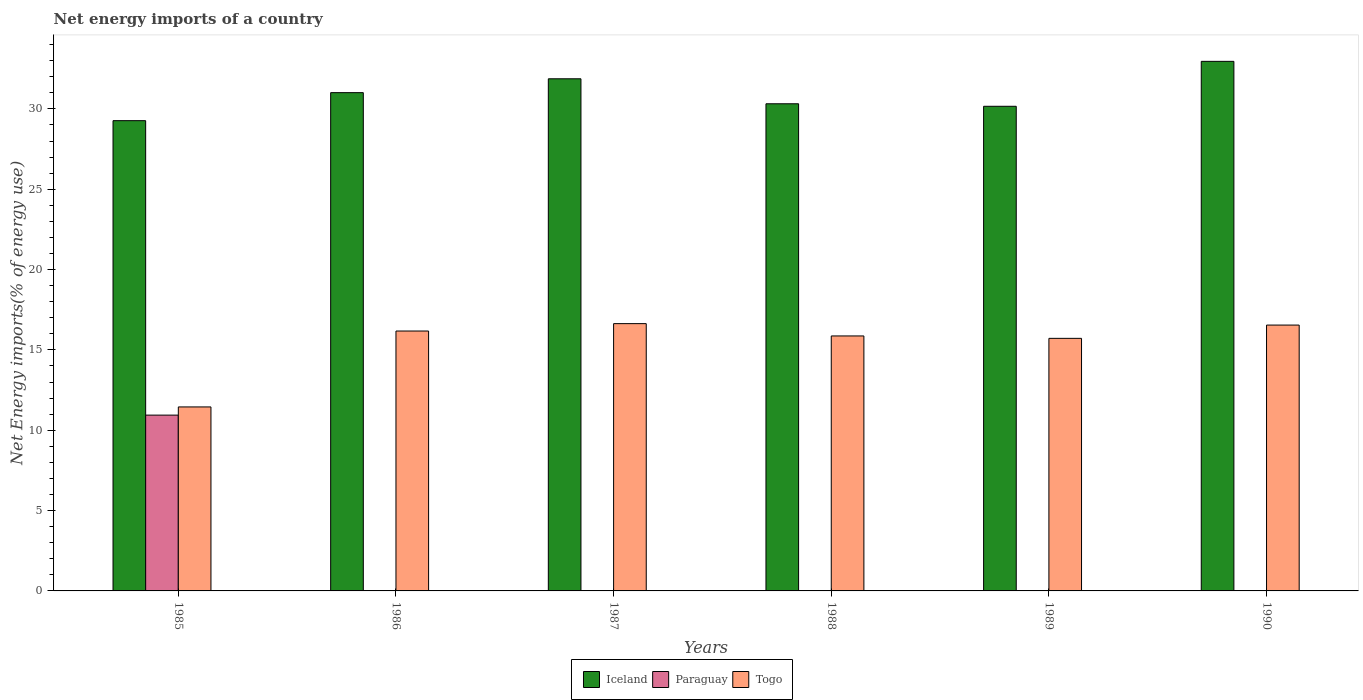How many different coloured bars are there?
Give a very brief answer. 3. Are the number of bars on each tick of the X-axis equal?
Provide a succinct answer. No. What is the net energy imports in Togo in 1988?
Your answer should be compact. 15.87. Across all years, what is the maximum net energy imports in Paraguay?
Keep it short and to the point. 10.94. Across all years, what is the minimum net energy imports in Togo?
Your response must be concise. 11.45. What is the total net energy imports in Paraguay in the graph?
Provide a short and direct response. 10.94. What is the difference between the net energy imports in Togo in 1989 and that in 1990?
Make the answer very short. -0.83. What is the difference between the net energy imports in Togo in 1987 and the net energy imports in Paraguay in 1985?
Offer a very short reply. 5.69. What is the average net energy imports in Iceland per year?
Offer a very short reply. 30.93. In the year 1989, what is the difference between the net energy imports in Iceland and net energy imports in Togo?
Keep it short and to the point. 14.44. What is the ratio of the net energy imports in Iceland in 1989 to that in 1990?
Give a very brief answer. 0.92. Is the net energy imports in Togo in 1989 less than that in 1990?
Provide a short and direct response. Yes. What is the difference between the highest and the second highest net energy imports in Iceland?
Provide a succinct answer. 1.08. What is the difference between the highest and the lowest net energy imports in Paraguay?
Your response must be concise. 10.94. In how many years, is the net energy imports in Togo greater than the average net energy imports in Togo taken over all years?
Provide a short and direct response. 5. Is the sum of the net energy imports in Togo in 1985 and 1988 greater than the maximum net energy imports in Iceland across all years?
Offer a terse response. No. How many bars are there?
Give a very brief answer. 13. Does the graph contain any zero values?
Ensure brevity in your answer.  Yes. Where does the legend appear in the graph?
Offer a very short reply. Bottom center. What is the title of the graph?
Ensure brevity in your answer.  Net energy imports of a country. Does "Botswana" appear as one of the legend labels in the graph?
Ensure brevity in your answer.  No. What is the label or title of the Y-axis?
Your answer should be very brief. Net Energy imports(% of energy use). What is the Net Energy imports(% of energy use) in Iceland in 1985?
Offer a terse response. 29.27. What is the Net Energy imports(% of energy use) of Paraguay in 1985?
Your response must be concise. 10.94. What is the Net Energy imports(% of energy use) in Togo in 1985?
Your answer should be compact. 11.45. What is the Net Energy imports(% of energy use) in Iceland in 1986?
Provide a short and direct response. 31.01. What is the Net Energy imports(% of energy use) of Paraguay in 1986?
Ensure brevity in your answer.  0. What is the Net Energy imports(% of energy use) in Togo in 1986?
Provide a succinct answer. 16.17. What is the Net Energy imports(% of energy use) in Iceland in 1987?
Keep it short and to the point. 31.87. What is the Net Energy imports(% of energy use) in Paraguay in 1987?
Your answer should be very brief. 0. What is the Net Energy imports(% of energy use) of Togo in 1987?
Your answer should be compact. 16.64. What is the Net Energy imports(% of energy use) in Iceland in 1988?
Your answer should be very brief. 30.32. What is the Net Energy imports(% of energy use) in Paraguay in 1988?
Give a very brief answer. 0. What is the Net Energy imports(% of energy use) in Togo in 1988?
Offer a very short reply. 15.87. What is the Net Energy imports(% of energy use) in Iceland in 1989?
Provide a succinct answer. 30.16. What is the Net Energy imports(% of energy use) in Togo in 1989?
Your response must be concise. 15.72. What is the Net Energy imports(% of energy use) of Iceland in 1990?
Your answer should be compact. 32.96. What is the Net Energy imports(% of energy use) in Paraguay in 1990?
Provide a succinct answer. 0. What is the Net Energy imports(% of energy use) of Togo in 1990?
Offer a very short reply. 16.55. Across all years, what is the maximum Net Energy imports(% of energy use) of Iceland?
Provide a succinct answer. 32.96. Across all years, what is the maximum Net Energy imports(% of energy use) of Paraguay?
Ensure brevity in your answer.  10.94. Across all years, what is the maximum Net Energy imports(% of energy use) of Togo?
Make the answer very short. 16.64. Across all years, what is the minimum Net Energy imports(% of energy use) in Iceland?
Provide a short and direct response. 29.27. Across all years, what is the minimum Net Energy imports(% of energy use) of Paraguay?
Ensure brevity in your answer.  0. Across all years, what is the minimum Net Energy imports(% of energy use) in Togo?
Provide a short and direct response. 11.45. What is the total Net Energy imports(% of energy use) of Iceland in the graph?
Your response must be concise. 185.59. What is the total Net Energy imports(% of energy use) of Paraguay in the graph?
Ensure brevity in your answer.  10.94. What is the total Net Energy imports(% of energy use) in Togo in the graph?
Your response must be concise. 92.39. What is the difference between the Net Energy imports(% of energy use) of Iceland in 1985 and that in 1986?
Your answer should be very brief. -1.74. What is the difference between the Net Energy imports(% of energy use) of Togo in 1985 and that in 1986?
Make the answer very short. -4.72. What is the difference between the Net Energy imports(% of energy use) of Iceland in 1985 and that in 1987?
Offer a terse response. -2.61. What is the difference between the Net Energy imports(% of energy use) of Togo in 1985 and that in 1987?
Provide a succinct answer. -5.18. What is the difference between the Net Energy imports(% of energy use) of Iceland in 1985 and that in 1988?
Give a very brief answer. -1.05. What is the difference between the Net Energy imports(% of energy use) in Togo in 1985 and that in 1988?
Offer a terse response. -4.42. What is the difference between the Net Energy imports(% of energy use) of Iceland in 1985 and that in 1989?
Your answer should be very brief. -0.9. What is the difference between the Net Energy imports(% of energy use) in Togo in 1985 and that in 1989?
Offer a very short reply. -4.27. What is the difference between the Net Energy imports(% of energy use) in Iceland in 1985 and that in 1990?
Make the answer very short. -3.69. What is the difference between the Net Energy imports(% of energy use) of Togo in 1985 and that in 1990?
Provide a short and direct response. -5.09. What is the difference between the Net Energy imports(% of energy use) of Iceland in 1986 and that in 1987?
Your answer should be very brief. -0.86. What is the difference between the Net Energy imports(% of energy use) in Togo in 1986 and that in 1987?
Your response must be concise. -0.46. What is the difference between the Net Energy imports(% of energy use) in Iceland in 1986 and that in 1988?
Give a very brief answer. 0.69. What is the difference between the Net Energy imports(% of energy use) in Togo in 1986 and that in 1988?
Provide a succinct answer. 0.31. What is the difference between the Net Energy imports(% of energy use) of Iceland in 1986 and that in 1989?
Offer a very short reply. 0.85. What is the difference between the Net Energy imports(% of energy use) in Togo in 1986 and that in 1989?
Your response must be concise. 0.46. What is the difference between the Net Energy imports(% of energy use) of Iceland in 1986 and that in 1990?
Keep it short and to the point. -1.95. What is the difference between the Net Energy imports(% of energy use) of Togo in 1986 and that in 1990?
Your answer should be compact. -0.37. What is the difference between the Net Energy imports(% of energy use) in Iceland in 1987 and that in 1988?
Your response must be concise. 1.56. What is the difference between the Net Energy imports(% of energy use) of Togo in 1987 and that in 1988?
Make the answer very short. 0.77. What is the difference between the Net Energy imports(% of energy use) of Iceland in 1987 and that in 1989?
Give a very brief answer. 1.71. What is the difference between the Net Energy imports(% of energy use) in Togo in 1987 and that in 1989?
Offer a very short reply. 0.92. What is the difference between the Net Energy imports(% of energy use) of Iceland in 1987 and that in 1990?
Offer a very short reply. -1.08. What is the difference between the Net Energy imports(% of energy use) of Togo in 1987 and that in 1990?
Offer a very short reply. 0.09. What is the difference between the Net Energy imports(% of energy use) of Iceland in 1988 and that in 1989?
Your answer should be compact. 0.16. What is the difference between the Net Energy imports(% of energy use) of Togo in 1988 and that in 1989?
Provide a short and direct response. 0.15. What is the difference between the Net Energy imports(% of energy use) of Iceland in 1988 and that in 1990?
Offer a very short reply. -2.64. What is the difference between the Net Energy imports(% of energy use) of Togo in 1988 and that in 1990?
Your answer should be compact. -0.68. What is the difference between the Net Energy imports(% of energy use) in Iceland in 1989 and that in 1990?
Offer a very short reply. -2.8. What is the difference between the Net Energy imports(% of energy use) of Togo in 1989 and that in 1990?
Provide a short and direct response. -0.83. What is the difference between the Net Energy imports(% of energy use) of Iceland in 1985 and the Net Energy imports(% of energy use) of Togo in 1986?
Your response must be concise. 13.09. What is the difference between the Net Energy imports(% of energy use) of Paraguay in 1985 and the Net Energy imports(% of energy use) of Togo in 1986?
Make the answer very short. -5.23. What is the difference between the Net Energy imports(% of energy use) in Iceland in 1985 and the Net Energy imports(% of energy use) in Togo in 1987?
Provide a short and direct response. 12.63. What is the difference between the Net Energy imports(% of energy use) in Paraguay in 1985 and the Net Energy imports(% of energy use) in Togo in 1987?
Your response must be concise. -5.69. What is the difference between the Net Energy imports(% of energy use) of Iceland in 1985 and the Net Energy imports(% of energy use) of Togo in 1988?
Offer a terse response. 13.4. What is the difference between the Net Energy imports(% of energy use) of Paraguay in 1985 and the Net Energy imports(% of energy use) of Togo in 1988?
Offer a terse response. -4.93. What is the difference between the Net Energy imports(% of energy use) of Iceland in 1985 and the Net Energy imports(% of energy use) of Togo in 1989?
Keep it short and to the point. 13.55. What is the difference between the Net Energy imports(% of energy use) in Paraguay in 1985 and the Net Energy imports(% of energy use) in Togo in 1989?
Your response must be concise. -4.78. What is the difference between the Net Energy imports(% of energy use) in Iceland in 1985 and the Net Energy imports(% of energy use) in Togo in 1990?
Your answer should be very brief. 12.72. What is the difference between the Net Energy imports(% of energy use) in Paraguay in 1985 and the Net Energy imports(% of energy use) in Togo in 1990?
Ensure brevity in your answer.  -5.6. What is the difference between the Net Energy imports(% of energy use) of Iceland in 1986 and the Net Energy imports(% of energy use) of Togo in 1987?
Give a very brief answer. 14.38. What is the difference between the Net Energy imports(% of energy use) of Iceland in 1986 and the Net Energy imports(% of energy use) of Togo in 1988?
Your response must be concise. 15.14. What is the difference between the Net Energy imports(% of energy use) of Iceland in 1986 and the Net Energy imports(% of energy use) of Togo in 1989?
Provide a short and direct response. 15.29. What is the difference between the Net Energy imports(% of energy use) of Iceland in 1986 and the Net Energy imports(% of energy use) of Togo in 1990?
Make the answer very short. 14.47. What is the difference between the Net Energy imports(% of energy use) in Iceland in 1987 and the Net Energy imports(% of energy use) in Togo in 1988?
Offer a terse response. 16. What is the difference between the Net Energy imports(% of energy use) in Iceland in 1987 and the Net Energy imports(% of energy use) in Togo in 1989?
Offer a very short reply. 16.15. What is the difference between the Net Energy imports(% of energy use) in Iceland in 1987 and the Net Energy imports(% of energy use) in Togo in 1990?
Provide a succinct answer. 15.33. What is the difference between the Net Energy imports(% of energy use) of Iceland in 1988 and the Net Energy imports(% of energy use) of Togo in 1989?
Provide a succinct answer. 14.6. What is the difference between the Net Energy imports(% of energy use) in Iceland in 1988 and the Net Energy imports(% of energy use) in Togo in 1990?
Ensure brevity in your answer.  13.77. What is the difference between the Net Energy imports(% of energy use) in Iceland in 1989 and the Net Energy imports(% of energy use) in Togo in 1990?
Ensure brevity in your answer.  13.62. What is the average Net Energy imports(% of energy use) in Iceland per year?
Give a very brief answer. 30.93. What is the average Net Energy imports(% of energy use) in Paraguay per year?
Your answer should be very brief. 1.82. What is the average Net Energy imports(% of energy use) in Togo per year?
Your answer should be compact. 15.4. In the year 1985, what is the difference between the Net Energy imports(% of energy use) of Iceland and Net Energy imports(% of energy use) of Paraguay?
Keep it short and to the point. 18.32. In the year 1985, what is the difference between the Net Energy imports(% of energy use) of Iceland and Net Energy imports(% of energy use) of Togo?
Ensure brevity in your answer.  17.82. In the year 1985, what is the difference between the Net Energy imports(% of energy use) of Paraguay and Net Energy imports(% of energy use) of Togo?
Your response must be concise. -0.51. In the year 1986, what is the difference between the Net Energy imports(% of energy use) in Iceland and Net Energy imports(% of energy use) in Togo?
Your answer should be very brief. 14.84. In the year 1987, what is the difference between the Net Energy imports(% of energy use) in Iceland and Net Energy imports(% of energy use) in Togo?
Provide a succinct answer. 15.24. In the year 1988, what is the difference between the Net Energy imports(% of energy use) of Iceland and Net Energy imports(% of energy use) of Togo?
Offer a very short reply. 14.45. In the year 1989, what is the difference between the Net Energy imports(% of energy use) in Iceland and Net Energy imports(% of energy use) in Togo?
Keep it short and to the point. 14.44. In the year 1990, what is the difference between the Net Energy imports(% of energy use) in Iceland and Net Energy imports(% of energy use) in Togo?
Your answer should be very brief. 16.41. What is the ratio of the Net Energy imports(% of energy use) of Iceland in 1985 to that in 1986?
Make the answer very short. 0.94. What is the ratio of the Net Energy imports(% of energy use) in Togo in 1985 to that in 1986?
Your response must be concise. 0.71. What is the ratio of the Net Energy imports(% of energy use) in Iceland in 1985 to that in 1987?
Your response must be concise. 0.92. What is the ratio of the Net Energy imports(% of energy use) of Togo in 1985 to that in 1987?
Offer a terse response. 0.69. What is the ratio of the Net Energy imports(% of energy use) in Iceland in 1985 to that in 1988?
Your response must be concise. 0.97. What is the ratio of the Net Energy imports(% of energy use) in Togo in 1985 to that in 1988?
Provide a succinct answer. 0.72. What is the ratio of the Net Energy imports(% of energy use) of Iceland in 1985 to that in 1989?
Offer a terse response. 0.97. What is the ratio of the Net Energy imports(% of energy use) of Togo in 1985 to that in 1989?
Make the answer very short. 0.73. What is the ratio of the Net Energy imports(% of energy use) of Iceland in 1985 to that in 1990?
Keep it short and to the point. 0.89. What is the ratio of the Net Energy imports(% of energy use) in Togo in 1985 to that in 1990?
Provide a short and direct response. 0.69. What is the ratio of the Net Energy imports(% of energy use) in Iceland in 1986 to that in 1987?
Your answer should be very brief. 0.97. What is the ratio of the Net Energy imports(% of energy use) of Togo in 1986 to that in 1987?
Your response must be concise. 0.97. What is the ratio of the Net Energy imports(% of energy use) in Iceland in 1986 to that in 1988?
Ensure brevity in your answer.  1.02. What is the ratio of the Net Energy imports(% of energy use) of Togo in 1986 to that in 1988?
Offer a very short reply. 1.02. What is the ratio of the Net Energy imports(% of energy use) of Iceland in 1986 to that in 1989?
Ensure brevity in your answer.  1.03. What is the ratio of the Net Energy imports(% of energy use) in Iceland in 1986 to that in 1990?
Ensure brevity in your answer.  0.94. What is the ratio of the Net Energy imports(% of energy use) of Togo in 1986 to that in 1990?
Make the answer very short. 0.98. What is the ratio of the Net Energy imports(% of energy use) in Iceland in 1987 to that in 1988?
Provide a succinct answer. 1.05. What is the ratio of the Net Energy imports(% of energy use) in Togo in 1987 to that in 1988?
Keep it short and to the point. 1.05. What is the ratio of the Net Energy imports(% of energy use) of Iceland in 1987 to that in 1989?
Offer a terse response. 1.06. What is the ratio of the Net Energy imports(% of energy use) of Togo in 1987 to that in 1989?
Provide a short and direct response. 1.06. What is the ratio of the Net Energy imports(% of energy use) in Iceland in 1987 to that in 1990?
Your answer should be compact. 0.97. What is the ratio of the Net Energy imports(% of energy use) of Togo in 1987 to that in 1990?
Offer a terse response. 1.01. What is the ratio of the Net Energy imports(% of energy use) of Togo in 1988 to that in 1989?
Ensure brevity in your answer.  1.01. What is the ratio of the Net Energy imports(% of energy use) of Iceland in 1988 to that in 1990?
Give a very brief answer. 0.92. What is the ratio of the Net Energy imports(% of energy use) of Togo in 1988 to that in 1990?
Ensure brevity in your answer.  0.96. What is the ratio of the Net Energy imports(% of energy use) of Iceland in 1989 to that in 1990?
Provide a succinct answer. 0.92. What is the ratio of the Net Energy imports(% of energy use) in Togo in 1989 to that in 1990?
Keep it short and to the point. 0.95. What is the difference between the highest and the second highest Net Energy imports(% of energy use) of Iceland?
Keep it short and to the point. 1.08. What is the difference between the highest and the second highest Net Energy imports(% of energy use) of Togo?
Ensure brevity in your answer.  0.09. What is the difference between the highest and the lowest Net Energy imports(% of energy use) in Iceland?
Offer a very short reply. 3.69. What is the difference between the highest and the lowest Net Energy imports(% of energy use) of Paraguay?
Your response must be concise. 10.94. What is the difference between the highest and the lowest Net Energy imports(% of energy use) of Togo?
Offer a terse response. 5.18. 